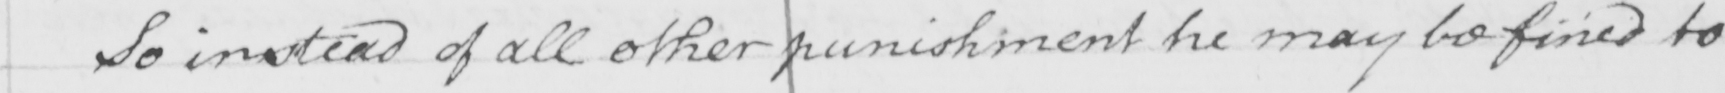Please provide the text content of this handwritten line. So instead of all other punishment he may be fined to 